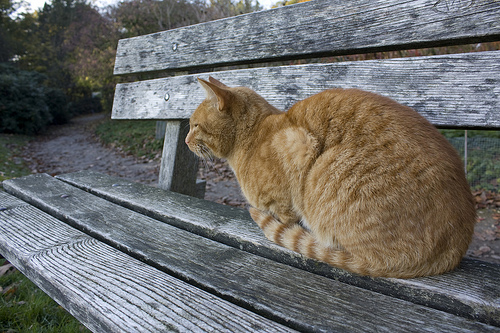What is the cat on? The cat is sitting on a bench. 